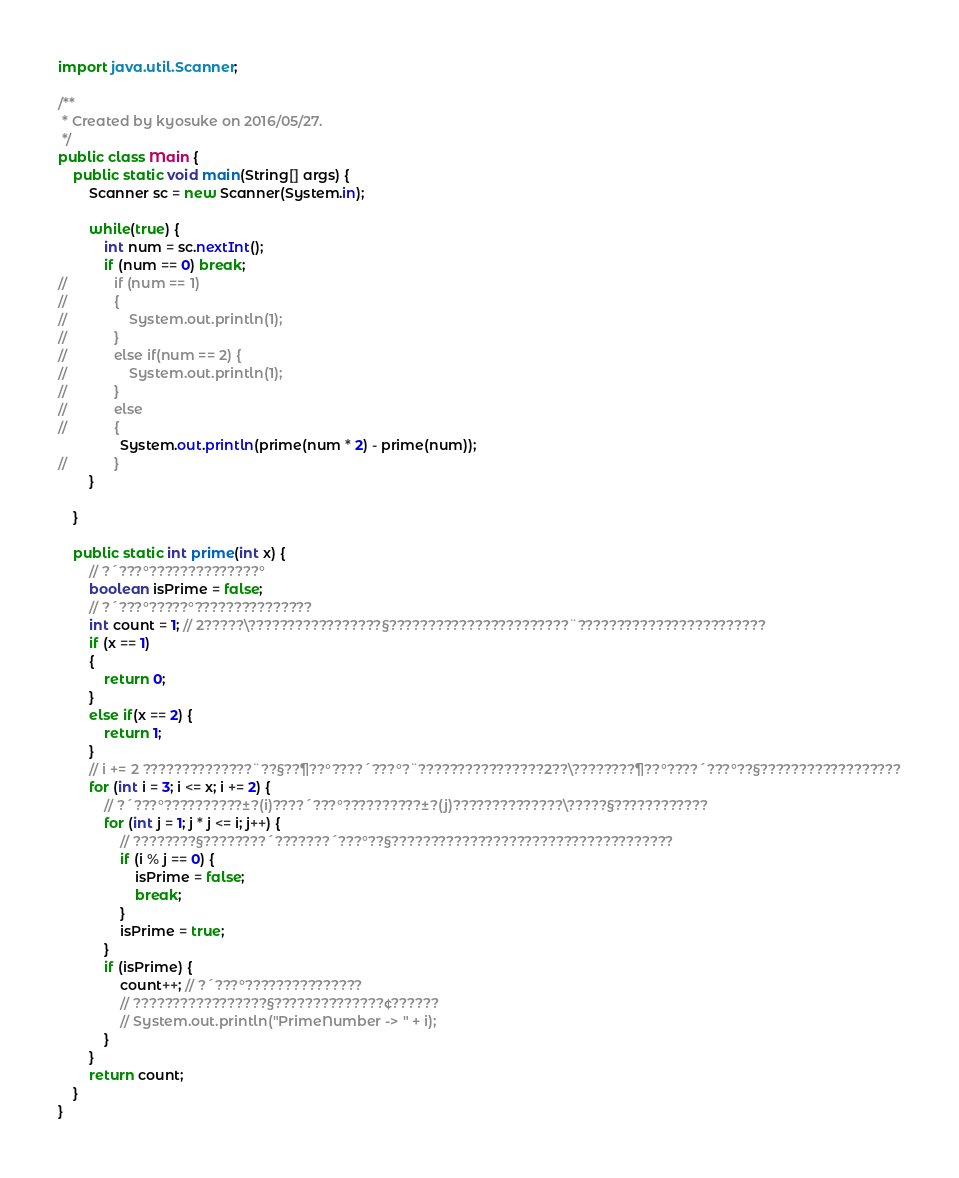Convert code to text. <code><loc_0><loc_0><loc_500><loc_500><_Java_>

import java.util.Scanner;

/**
 * Created by kyosuke on 2016/05/27.
 */
public class Main {
    public static void main(String[] args) {
        Scanner sc = new Scanner(System.in);

        while(true) {
            int num = sc.nextInt();
            if (num == 0) break;
//            if (num == 1)
//            {
//                System.out.println(1);
//            }
//            else if(num == 2) {
//                System.out.println(1);
//            }
//            else
//            {
                System.out.println(prime(num * 2) - prime(num));
//            }
        }

    }

    public static int prime(int x) {
        // ?´???°??????????????°
        boolean isPrime = false;
        // ?´???°?????°???????????????
        int count = 1; // 2?????\?????????????????§???????????????????????¨????????????????????????
        if (x == 1)
        {
            return 0;
        }
        else if(x == 2) {
            return 1;
        }
        // i += 2 ??????????????¨??§??¶??°????´???°?¨????????????????2??\????????¶??°????´???°??§??????????????????
        for (int i = 3; i <= x; i += 2) {
            // ?´???°??????????±?(i)????´???°??????????±?(j)??????????????\?????§????????????
            for (int j = 1; j * j <= i; j++) {
                // ????????§????????´???????´???°??§????????????????????????????????????
                if (i % j == 0) {
                    isPrime = false;
                    break;
                }
                isPrime = true;
            }
            if (isPrime) {
                count++; // ?´???°???????????????
                // ?????????????????§??????????????¢??????
                // System.out.println("PrimeNumber -> " + i);
            }
        }
        return count;
    }
}</code> 